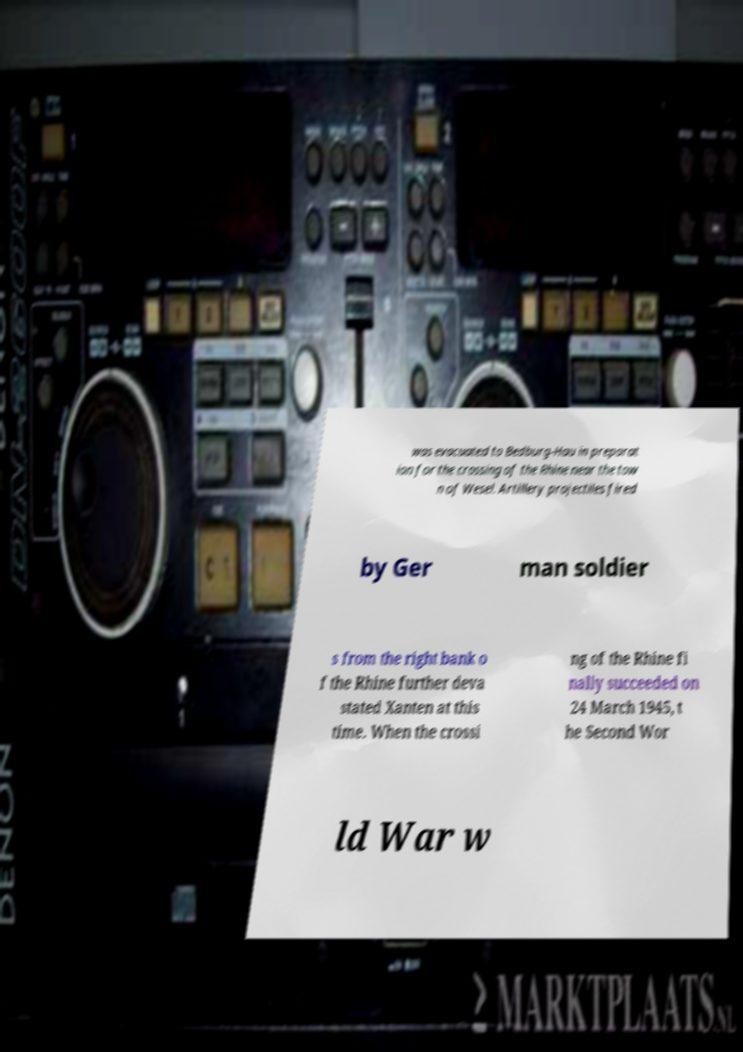Could you assist in decoding the text presented in this image and type it out clearly? was evacuated to Bedburg-Hau in preparat ion for the crossing of the Rhine near the tow n of Wesel. Artillery projectiles fired by Ger man soldier s from the right bank o f the Rhine further deva stated Xanten at this time. When the crossi ng of the Rhine fi nally succeeded on 24 March 1945, t he Second Wor ld War w 